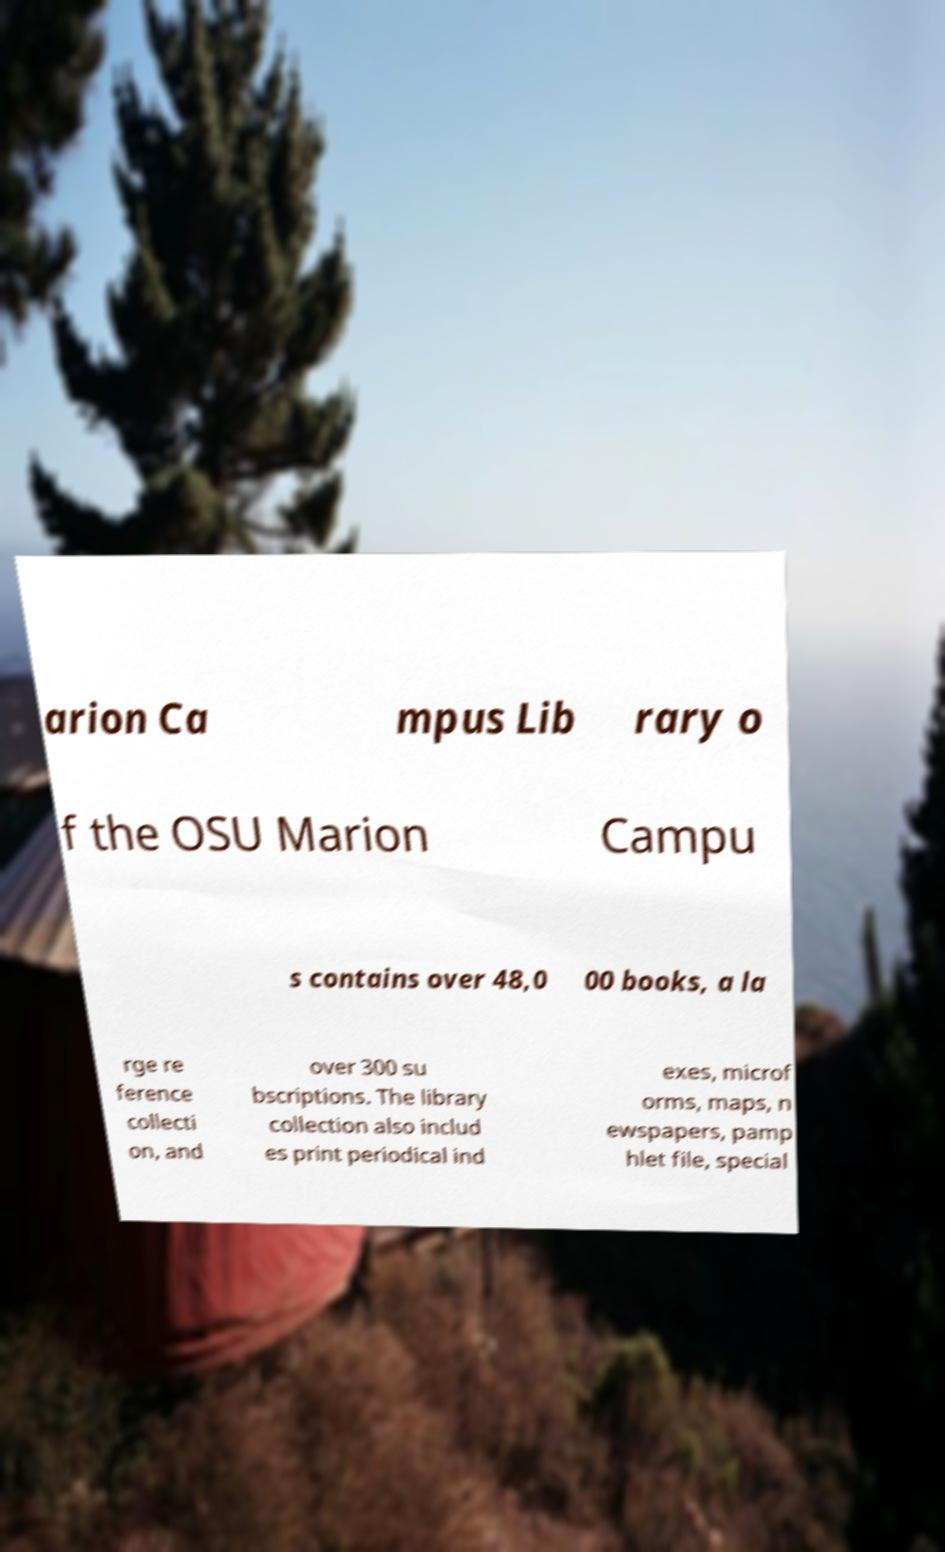For documentation purposes, I need the text within this image transcribed. Could you provide that? arion Ca mpus Lib rary o f the OSU Marion Campu s contains over 48,0 00 books, a la rge re ference collecti on, and over 300 su bscriptions. The library collection also includ es print periodical ind exes, microf orms, maps, n ewspapers, pamp hlet file, special 